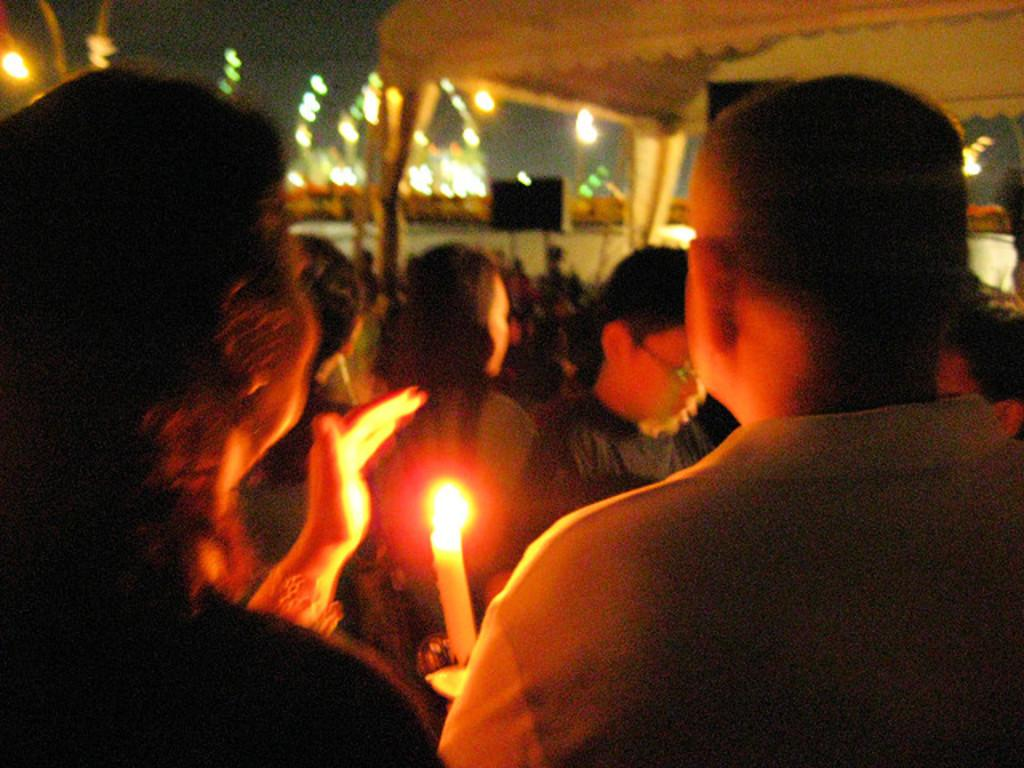What can be seen in the image? There are people standing in the image, along with a candle. What is visible in the background of the image? In the background, there are more people standing, a tent, lights, a board, and a dark sky. How many people are visible in the image? There are multiple people visible in the image, both in the foreground and background. What is the purpose of the board in the background? The purpose of the board in the background is not specified in the facts provided. What type of jam is being spread on the cord in the image? There is no jam or cord present in the image. How many trucks are visible in the image? There are no trucks visible in the image. 